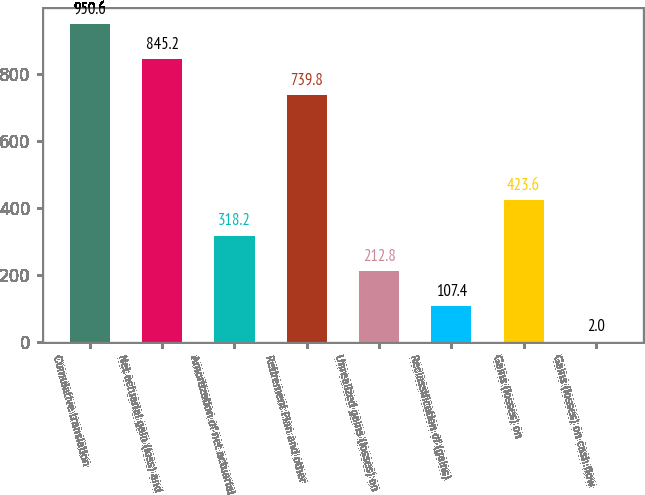<chart> <loc_0><loc_0><loc_500><loc_500><bar_chart><fcel>Cumulative translation<fcel>Net actuarial gain (loss) and<fcel>Amortization of net actuarial<fcel>Retirement Plan and other<fcel>Unrealized gains (losses) on<fcel>Reclassification of (gains)<fcel>Gains (losses) on<fcel>Gains (losses) on cash flow<nl><fcel>950.6<fcel>845.2<fcel>318.2<fcel>739.8<fcel>212.8<fcel>107.4<fcel>423.6<fcel>2<nl></chart> 